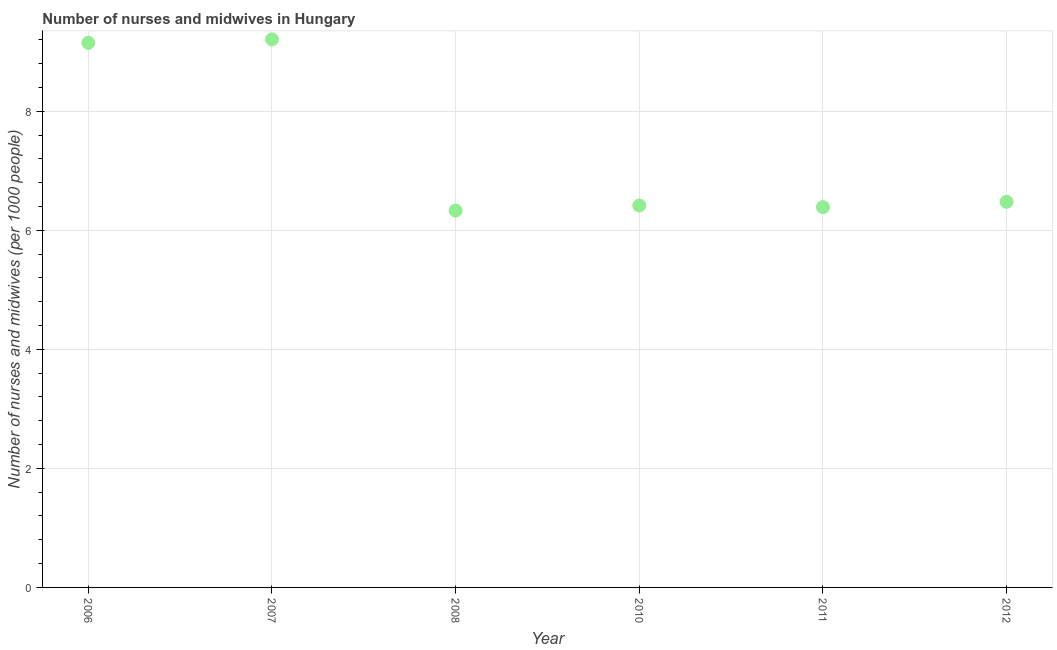What is the number of nurses and midwives in 2011?
Your response must be concise. 6.39. Across all years, what is the maximum number of nurses and midwives?
Offer a terse response. 9.21. Across all years, what is the minimum number of nurses and midwives?
Provide a short and direct response. 6.33. In which year was the number of nurses and midwives maximum?
Keep it short and to the point. 2007. What is the sum of the number of nurses and midwives?
Your answer should be compact. 43.97. What is the difference between the number of nurses and midwives in 2006 and 2008?
Provide a succinct answer. 2.82. What is the average number of nurses and midwives per year?
Give a very brief answer. 7.33. What is the median number of nurses and midwives?
Offer a very short reply. 6.45. Do a majority of the years between 2007 and 2010 (inclusive) have number of nurses and midwives greater than 6.4 ?
Your answer should be compact. Yes. What is the ratio of the number of nurses and midwives in 2006 to that in 2011?
Keep it short and to the point. 1.43. What is the difference between the highest and the second highest number of nurses and midwives?
Give a very brief answer. 0.06. Is the sum of the number of nurses and midwives in 2006 and 2011 greater than the maximum number of nurses and midwives across all years?
Ensure brevity in your answer.  Yes. What is the difference between the highest and the lowest number of nurses and midwives?
Give a very brief answer. 2.88. In how many years, is the number of nurses and midwives greater than the average number of nurses and midwives taken over all years?
Offer a terse response. 2. What is the difference between two consecutive major ticks on the Y-axis?
Give a very brief answer. 2. Does the graph contain any zero values?
Offer a very short reply. No. What is the title of the graph?
Make the answer very short. Number of nurses and midwives in Hungary. What is the label or title of the Y-axis?
Offer a very short reply. Number of nurses and midwives (per 1000 people). What is the Number of nurses and midwives (per 1000 people) in 2006?
Ensure brevity in your answer.  9.15. What is the Number of nurses and midwives (per 1000 people) in 2007?
Your answer should be very brief. 9.21. What is the Number of nurses and midwives (per 1000 people) in 2008?
Give a very brief answer. 6.33. What is the Number of nurses and midwives (per 1000 people) in 2010?
Give a very brief answer. 6.42. What is the Number of nurses and midwives (per 1000 people) in 2011?
Ensure brevity in your answer.  6.39. What is the Number of nurses and midwives (per 1000 people) in 2012?
Make the answer very short. 6.48. What is the difference between the Number of nurses and midwives (per 1000 people) in 2006 and 2007?
Ensure brevity in your answer.  -0.06. What is the difference between the Number of nurses and midwives (per 1000 people) in 2006 and 2008?
Offer a very short reply. 2.82. What is the difference between the Number of nurses and midwives (per 1000 people) in 2006 and 2010?
Ensure brevity in your answer.  2.73. What is the difference between the Number of nurses and midwives (per 1000 people) in 2006 and 2011?
Make the answer very short. 2.76. What is the difference between the Number of nurses and midwives (per 1000 people) in 2006 and 2012?
Your answer should be compact. 2.67. What is the difference between the Number of nurses and midwives (per 1000 people) in 2007 and 2008?
Make the answer very short. 2.88. What is the difference between the Number of nurses and midwives (per 1000 people) in 2007 and 2010?
Offer a very short reply. 2.79. What is the difference between the Number of nurses and midwives (per 1000 people) in 2007 and 2011?
Make the answer very short. 2.82. What is the difference between the Number of nurses and midwives (per 1000 people) in 2007 and 2012?
Make the answer very short. 2.73. What is the difference between the Number of nurses and midwives (per 1000 people) in 2008 and 2010?
Ensure brevity in your answer.  -0.09. What is the difference between the Number of nurses and midwives (per 1000 people) in 2008 and 2011?
Your response must be concise. -0.06. What is the difference between the Number of nurses and midwives (per 1000 people) in 2008 and 2012?
Provide a short and direct response. -0.15. What is the difference between the Number of nurses and midwives (per 1000 people) in 2010 and 2011?
Offer a terse response. 0.03. What is the difference between the Number of nurses and midwives (per 1000 people) in 2010 and 2012?
Give a very brief answer. -0.06. What is the difference between the Number of nurses and midwives (per 1000 people) in 2011 and 2012?
Your answer should be very brief. -0.09. What is the ratio of the Number of nurses and midwives (per 1000 people) in 2006 to that in 2007?
Provide a short and direct response. 0.99. What is the ratio of the Number of nurses and midwives (per 1000 people) in 2006 to that in 2008?
Your response must be concise. 1.45. What is the ratio of the Number of nurses and midwives (per 1000 people) in 2006 to that in 2010?
Ensure brevity in your answer.  1.43. What is the ratio of the Number of nurses and midwives (per 1000 people) in 2006 to that in 2011?
Offer a very short reply. 1.43. What is the ratio of the Number of nurses and midwives (per 1000 people) in 2006 to that in 2012?
Provide a succinct answer. 1.41. What is the ratio of the Number of nurses and midwives (per 1000 people) in 2007 to that in 2008?
Ensure brevity in your answer.  1.46. What is the ratio of the Number of nurses and midwives (per 1000 people) in 2007 to that in 2010?
Give a very brief answer. 1.44. What is the ratio of the Number of nurses and midwives (per 1000 people) in 2007 to that in 2011?
Ensure brevity in your answer.  1.44. What is the ratio of the Number of nurses and midwives (per 1000 people) in 2007 to that in 2012?
Your answer should be compact. 1.42. What is the ratio of the Number of nurses and midwives (per 1000 people) in 2008 to that in 2010?
Provide a succinct answer. 0.99. What is the ratio of the Number of nurses and midwives (per 1000 people) in 2008 to that in 2012?
Your answer should be compact. 0.98. What is the ratio of the Number of nurses and midwives (per 1000 people) in 2010 to that in 2011?
Offer a terse response. 1. 